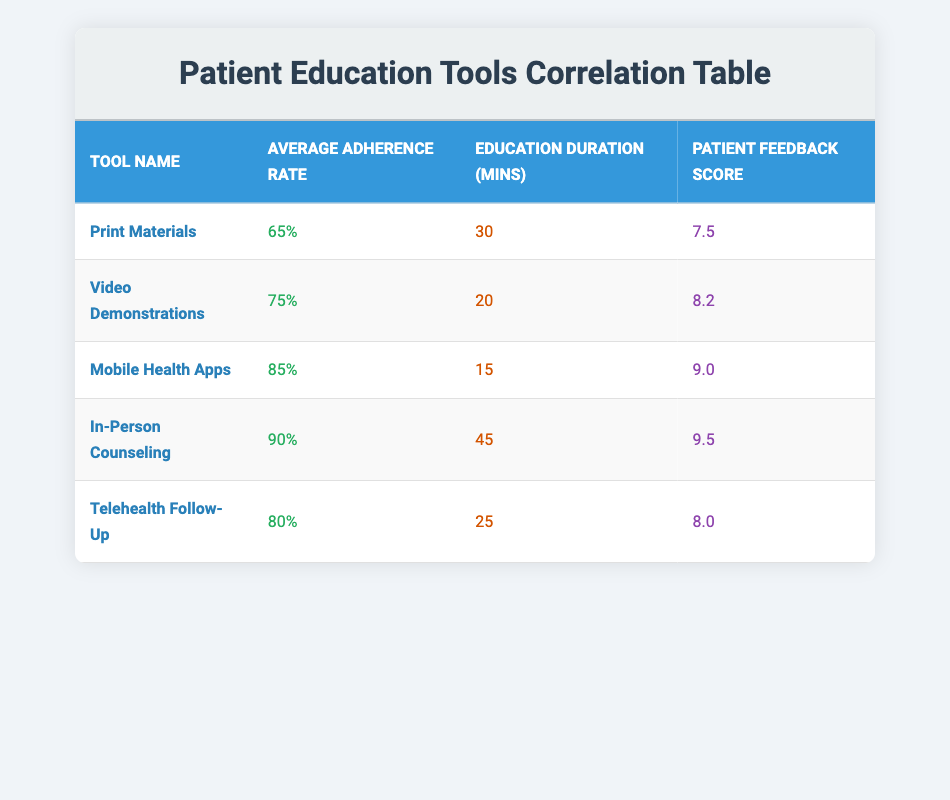What is the average adherence rate for all the tools combined? To calculate the average adherence rate, sum the adherence rates of all education tools: (65 + 75 + 85 + 90 + 80) = 395. Then, divide by the number of tools, which is 5: 395 / 5 = 79.
Answer: 79 Which patient education tool has the highest average adherence rate? By reviewing the adherence rates, "In-Person Counseling" has the highest average adherence rate at 90%.
Answer: In-Person Counseling Is the average adherence rate above 80% for all education tools? Looking at the table, the adherence rates are 65, 75, 85, 90, and 80. Since the rates for "Print Materials" and "Video Demonstrations" are below 80%, the statement is false.
Answer: No How does the education duration of "Mobile Health Apps" compare to "Video Demonstrations"? The education duration for "Mobile Health Apps" is 15 minutes while for "Video Demonstrations" it is 20 minutes. Therefore, "Mobile Health Apps" has a shorter duration by 5 minutes.
Answer: 5 minutes shorter What is the relationship between patient feedback scores and average adherence rates? Upon analysis, as the patient feedback score increases from 7.5 (Print Materials) to 9.5 (In-Person Counseling), there is a corresponding increase in average adherence rates from 65% to 90%. This indicates a positive correlation.
Answer: Positive correlation Which education tool has the lowest patient feedback score? The "Print Materials" has the lowest patient feedback score at 7.5.
Answer: Print Materials Is there a patient education tool that exceeded an adherence rate of 85% and also had a feedback score over 9.0? Yes, "In-Person Counseling" exceeded an adherence rate of 90% and has a feedback score of 9.5, meeting both criteria.
Answer: Yes What percentage increase in adherence rate does "Telehealth Follow-Up" have compared to "Print Materials"? The adherence rate for "Telehealth Follow-Up" is 80% and for "Print Materials" it is 65%. The difference is 80 - 65 = 15. To find the percentage increase: (15 / 65) * 100 = 23.08%.
Answer: 23.08% 